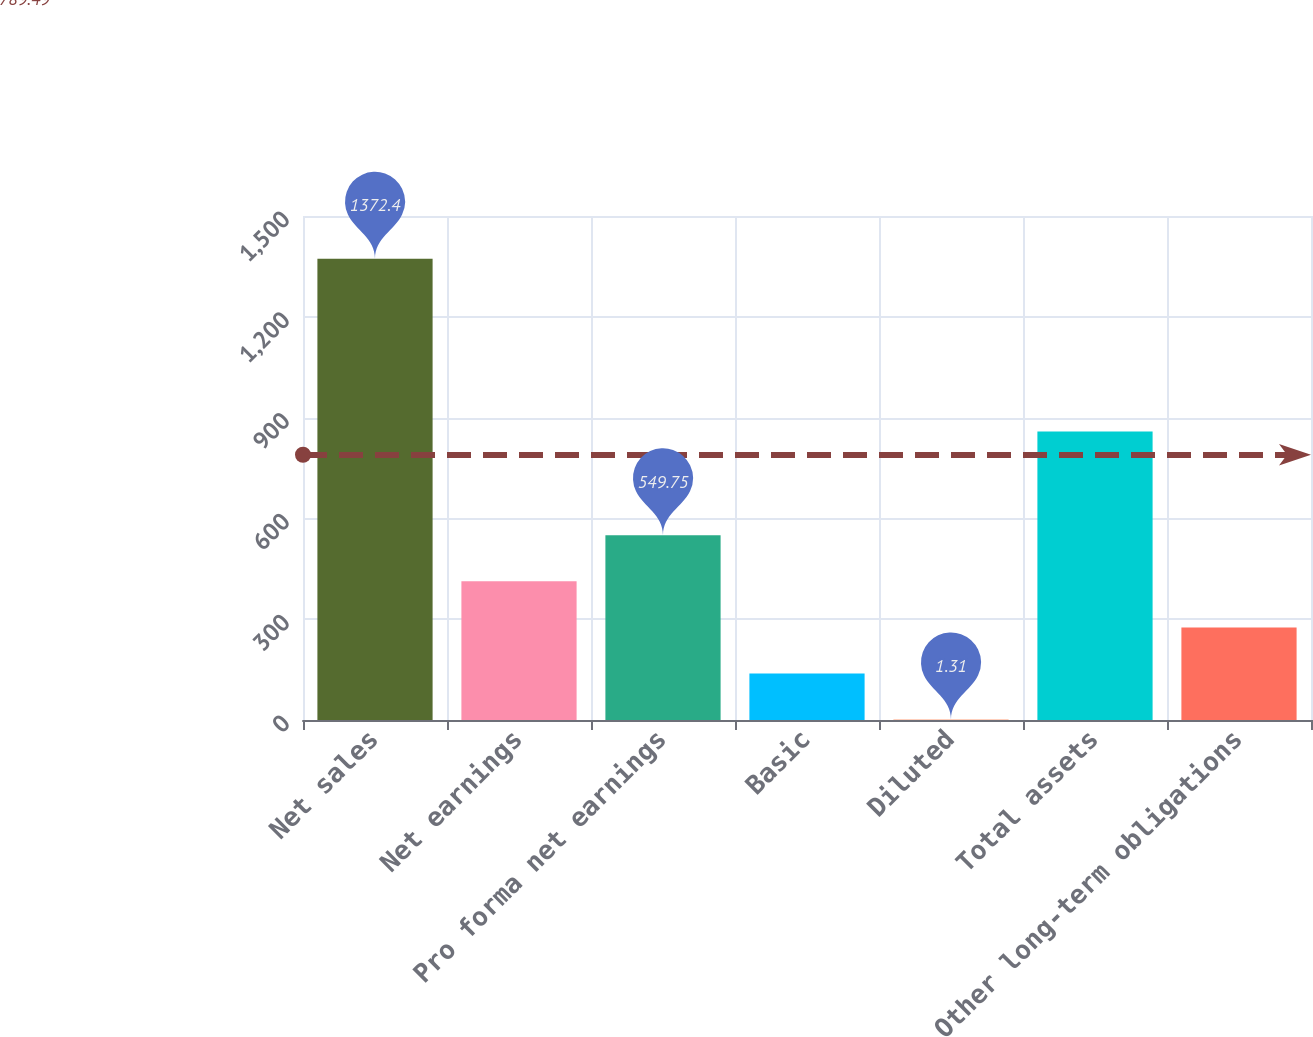<chart> <loc_0><loc_0><loc_500><loc_500><bar_chart><fcel>Net sales<fcel>Net earnings<fcel>Pro forma net earnings<fcel>Basic<fcel>Diluted<fcel>Total assets<fcel>Other long-term obligations<nl><fcel>1372.4<fcel>412.64<fcel>549.75<fcel>138.42<fcel>1.31<fcel>858.9<fcel>275.53<nl></chart> 